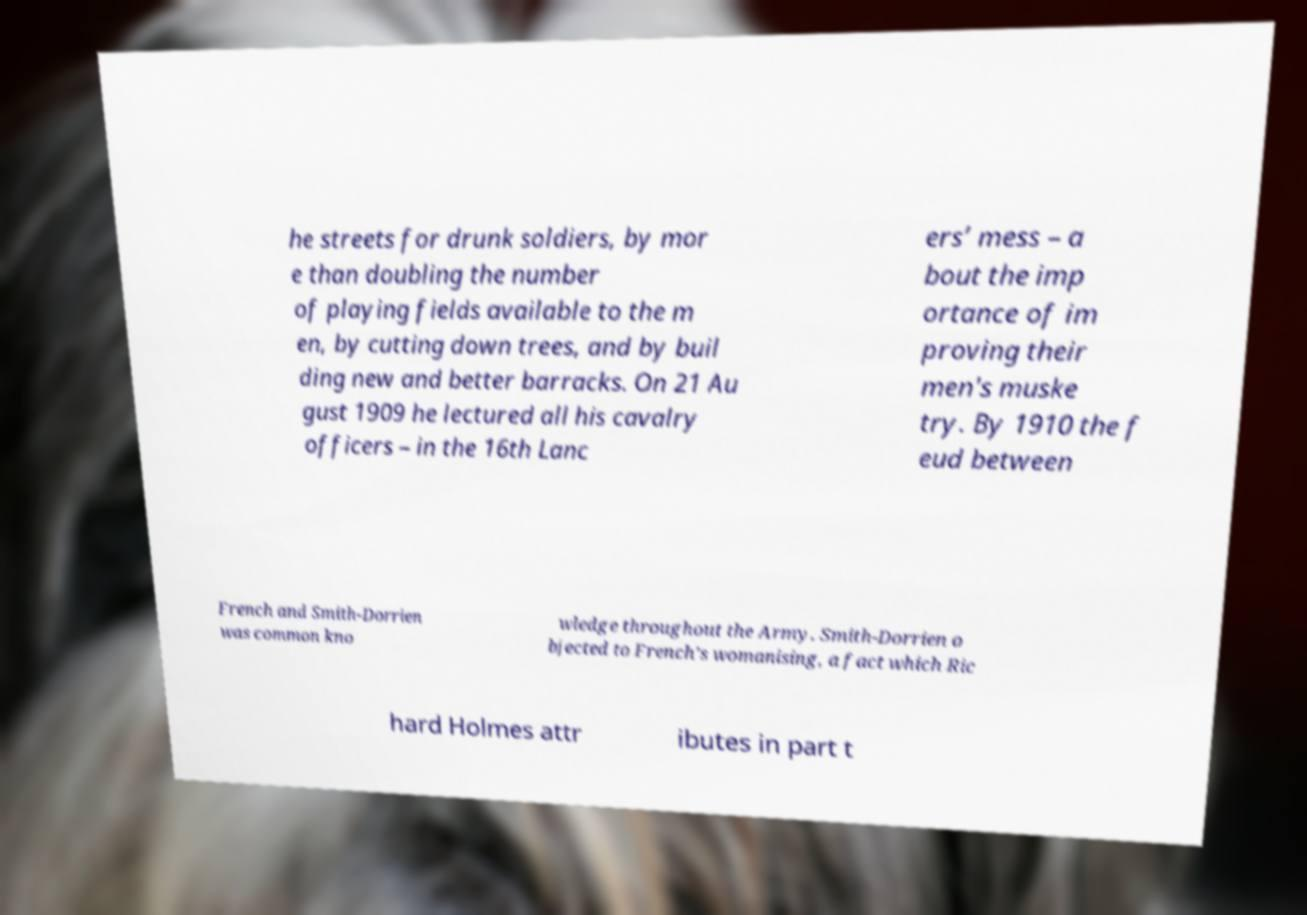Could you assist in decoding the text presented in this image and type it out clearly? he streets for drunk soldiers, by mor e than doubling the number of playing fields available to the m en, by cutting down trees, and by buil ding new and better barracks. On 21 Au gust 1909 he lectured all his cavalry officers – in the 16th Lanc ers’ mess – a bout the imp ortance of im proving their men's muske try. By 1910 the f eud between French and Smith-Dorrien was common kno wledge throughout the Army. Smith-Dorrien o bjected to French’s womanising, a fact which Ric hard Holmes attr ibutes in part t 